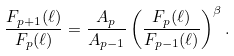Convert formula to latex. <formula><loc_0><loc_0><loc_500><loc_500>\frac { F _ { p + 1 } ( \ell ) } { F _ { p } ( \ell ) } = \frac { A _ { p } } { A _ { p - 1 } } \left ( \frac { F _ { p } ( \ell ) } { F _ { p - 1 } ( \ell ) } \right ) ^ { \beta } .</formula> 